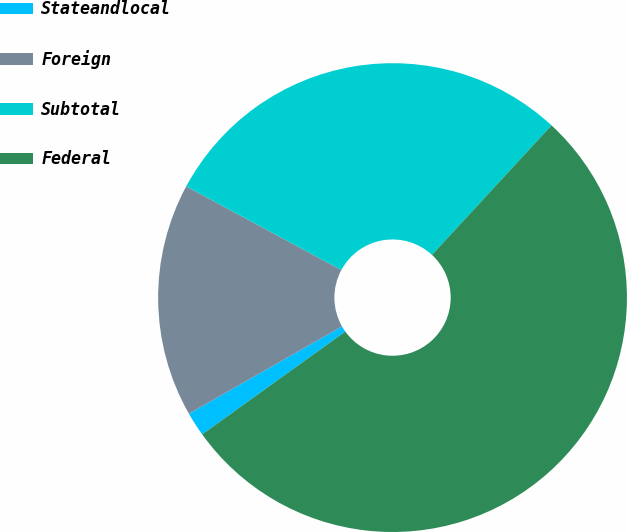Convert chart to OTSL. <chart><loc_0><loc_0><loc_500><loc_500><pie_chart><fcel>Stateandlocal<fcel>Foreign<fcel>Subtotal<fcel>Federal<nl><fcel>1.67%<fcel>16.12%<fcel>28.99%<fcel>53.22%<nl></chart> 